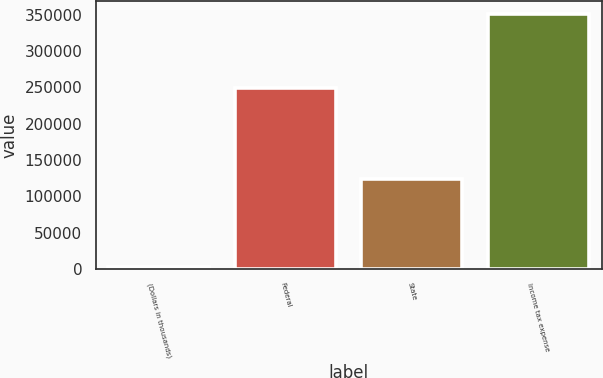Convert chart to OTSL. <chart><loc_0><loc_0><loc_500><loc_500><bar_chart><fcel>(Dollars in thousands)<fcel>Federal<fcel>State<fcel>Income tax expense<nl><fcel>2018<fcel>249358<fcel>123264<fcel>351561<nl></chart> 